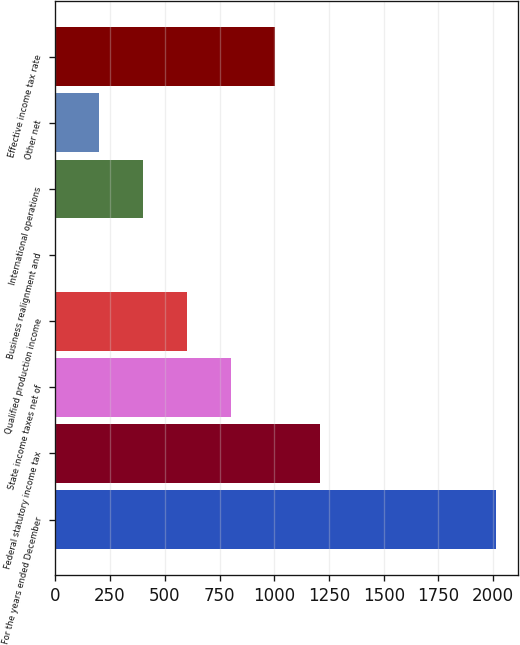Convert chart to OTSL. <chart><loc_0><loc_0><loc_500><loc_500><bar_chart><fcel>For the years ended December<fcel>Federal statutory income tax<fcel>State income taxes net of<fcel>Qualified production income<fcel>Business realignment and<fcel>International operations<fcel>Other net<fcel>Effective income tax rate<nl><fcel>2011<fcel>1206.64<fcel>804.46<fcel>603.37<fcel>0.1<fcel>402.28<fcel>201.19<fcel>1005.55<nl></chart> 